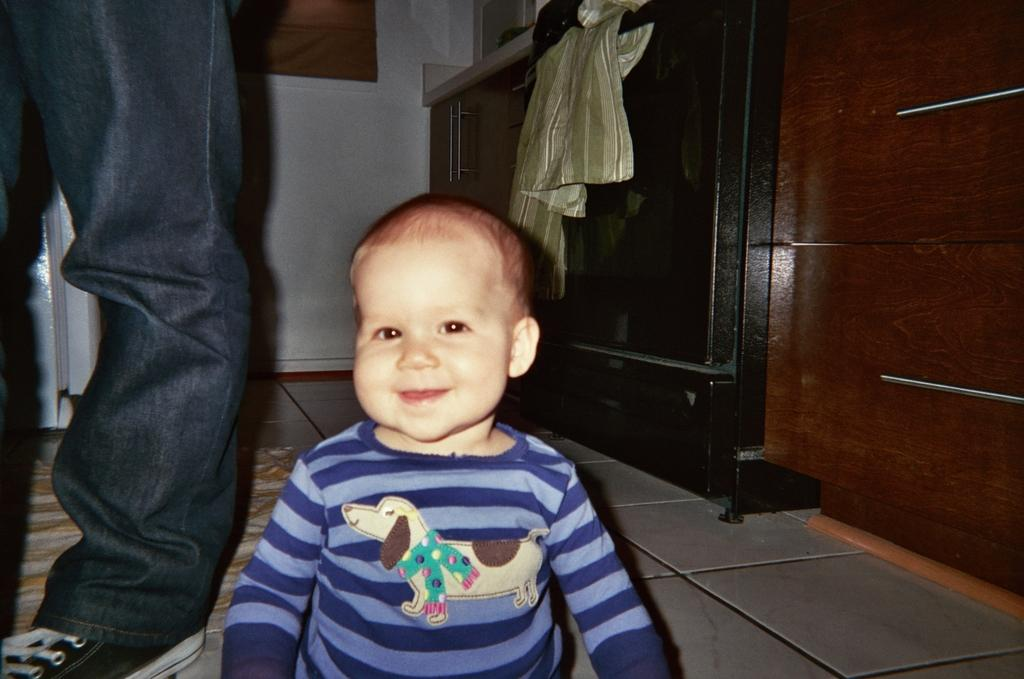What is the main subject of the image? There is a kid in the image. What can be seen on the floor in the image? There are legs of a person on the floor in the image. What is on the floor in the background of the image? There is a mat on the floor in the background of the image. What is visible in the background of the image? There is a wall and objects in the background of the image. What is on the cupboard table in the background of the image? There is a cloth on a cupboard table in the background of the image. What type of poison is being used to clean the cloth on the cupboard table in the image? There is no poison present in the image, and the cloth on the cupboard table is not being cleaned. 